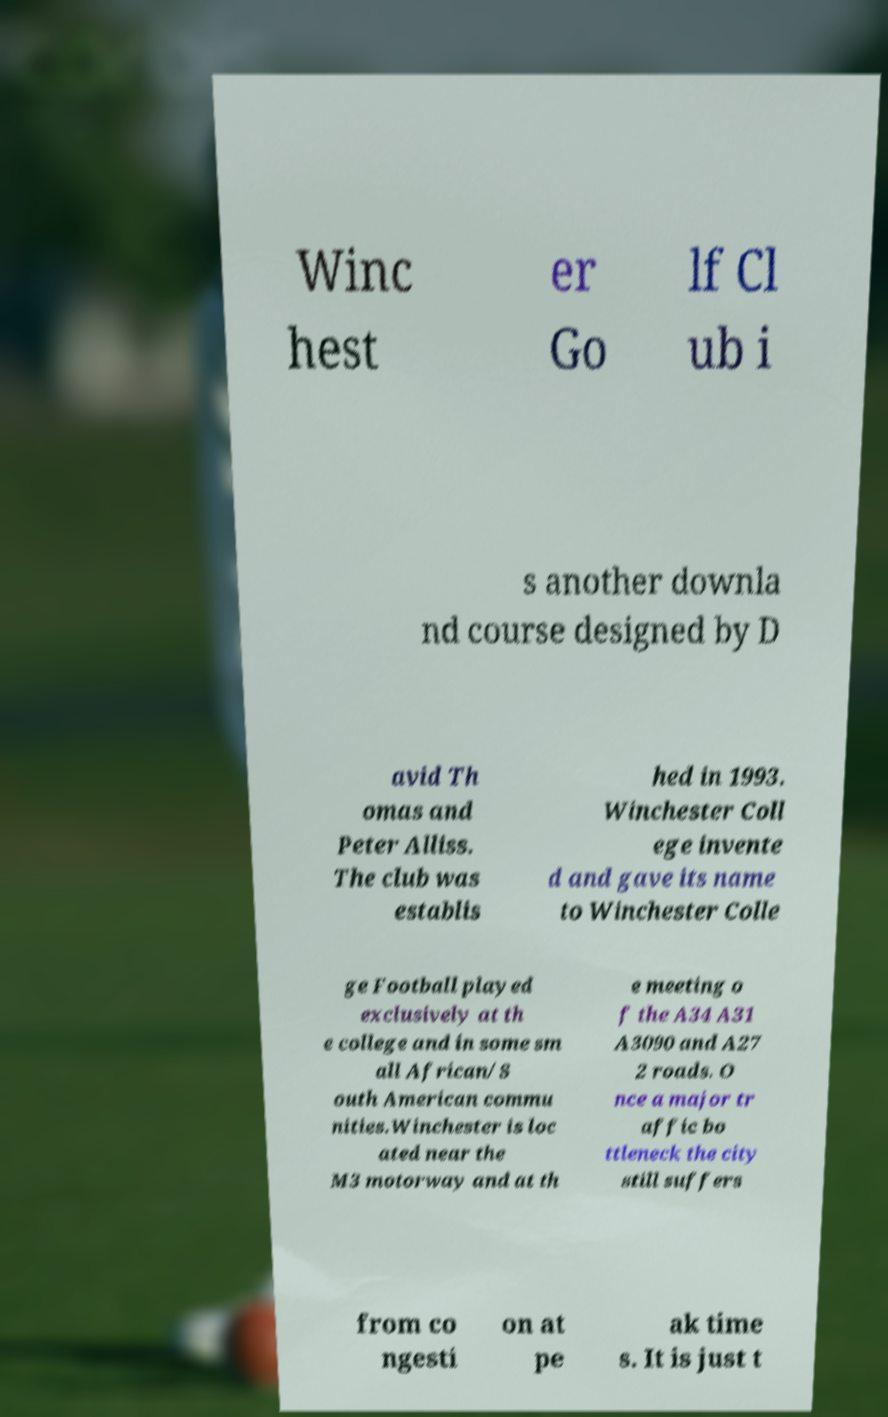Could you assist in decoding the text presented in this image and type it out clearly? Winc hest er Go lf Cl ub i s another downla nd course designed by D avid Th omas and Peter Alliss. The club was establis hed in 1993. Winchester Coll ege invente d and gave its name to Winchester Colle ge Football played exclusively at th e college and in some sm all African/S outh American commu nities.Winchester is loc ated near the M3 motorway and at th e meeting o f the A34 A31 A3090 and A27 2 roads. O nce a major tr affic bo ttleneck the city still suffers from co ngesti on at pe ak time s. It is just t 